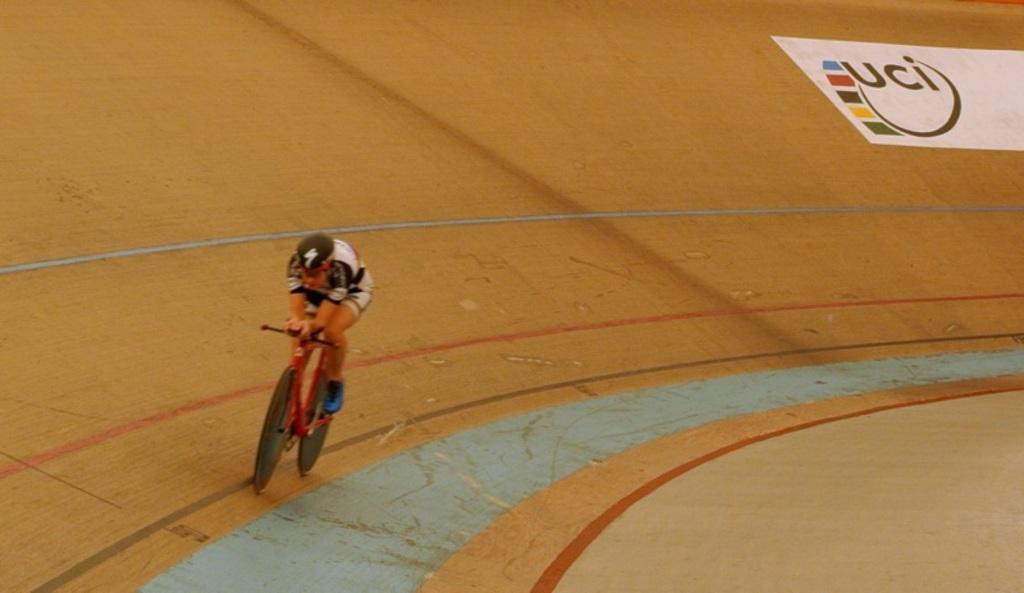Can you describe this image briefly? In the center of the image there is a person cycling on the cycling track. 